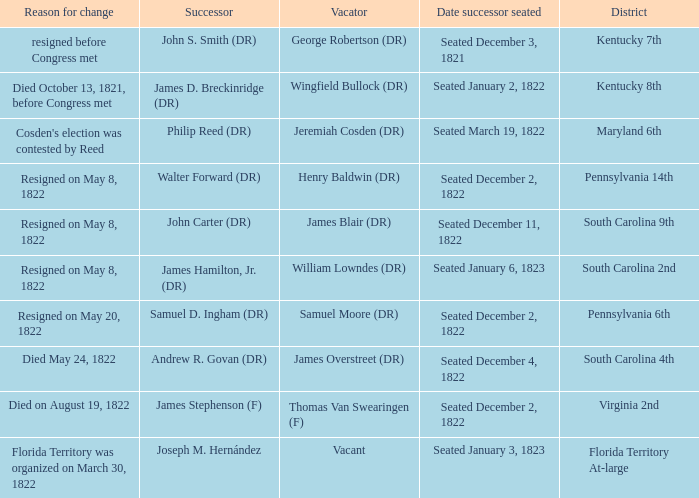In the 4th district of south carolina, who is the person in the role of vacator? James Overstreet (DR). 